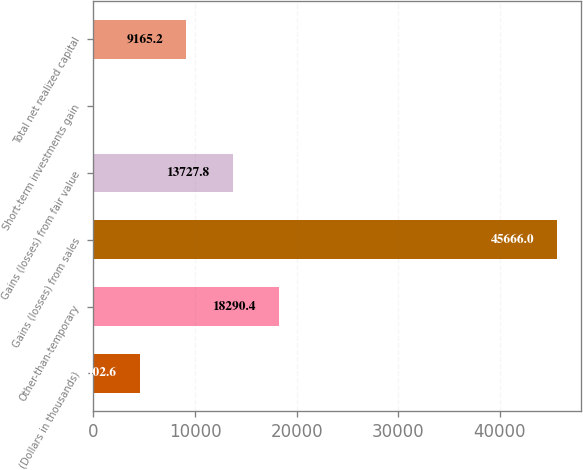Convert chart to OTSL. <chart><loc_0><loc_0><loc_500><loc_500><bar_chart><fcel>(Dollars in thousands)<fcel>Other-than-temporary<fcel>Gains (losses) from sales<fcel>Gains (losses) from fair value<fcel>Short-term investments gain<fcel>Total net realized capital<nl><fcel>4602.6<fcel>18290.4<fcel>45666<fcel>13727.8<fcel>40<fcel>9165.2<nl></chart> 